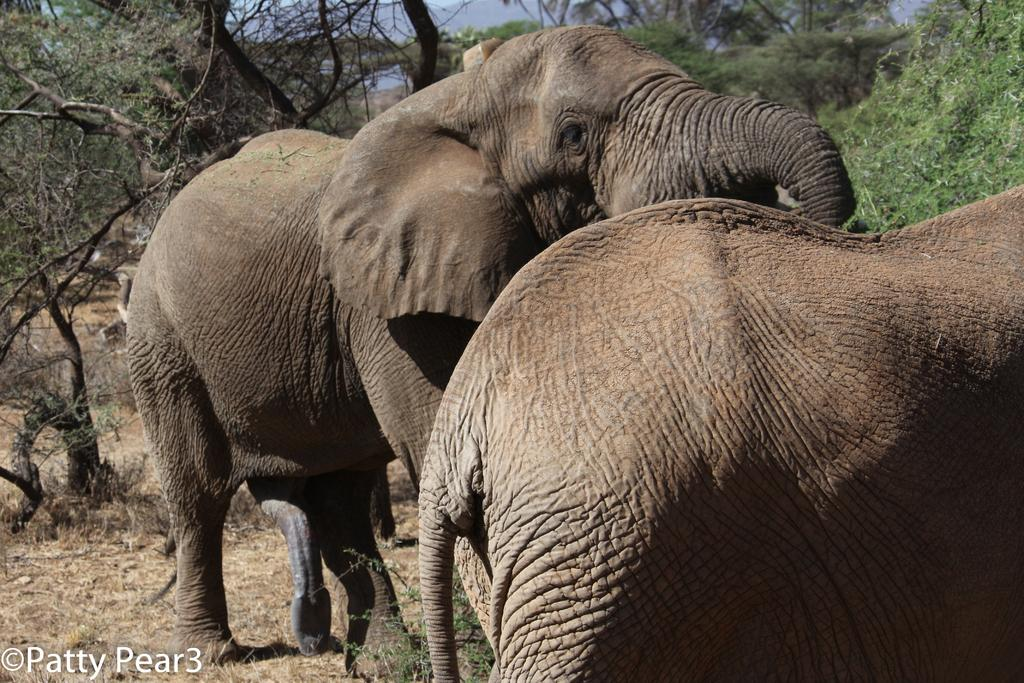What animals can be seen in the image? There are elephants in the image. What type of vegetation is present in the image? There are trees in the image. What is the ground cover in the image? Dry grass is visible in the image. What is visible in the background of the image? The sky is visible in the image. How many baskets are being carried by the elephants in the image? There are no baskets present in the image; the elephants are not carrying anything. 